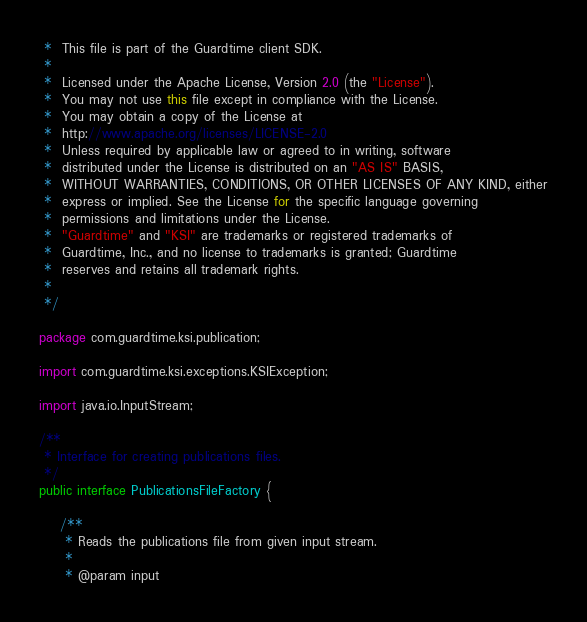<code> <loc_0><loc_0><loc_500><loc_500><_Java_> *  This file is part of the Guardtime client SDK.
 *
 *  Licensed under the Apache License, Version 2.0 (the "License").
 *  You may not use this file except in compliance with the License.
 *  You may obtain a copy of the License at
 *  http://www.apache.org/licenses/LICENSE-2.0
 *  Unless required by applicable law or agreed to in writing, software
 *  distributed under the License is distributed on an "AS IS" BASIS,
 *  WITHOUT WARRANTIES, CONDITIONS, OR OTHER LICENSES OF ANY KIND, either
 *  express or implied. See the License for the specific language governing
 *  permissions and limitations under the License.
 *  "Guardtime" and "KSI" are trademarks or registered trademarks of
 *  Guardtime, Inc., and no license to trademarks is granted; Guardtime
 *  reserves and retains all trademark rights.
 *
 */

package com.guardtime.ksi.publication;

import com.guardtime.ksi.exceptions.KSIException;

import java.io.InputStream;

/**
 * Interface for creating publications files.
 */
public interface PublicationsFileFactory {

    /**
     * Reads the publications file from given input stream.
     *
     * @param input</code> 